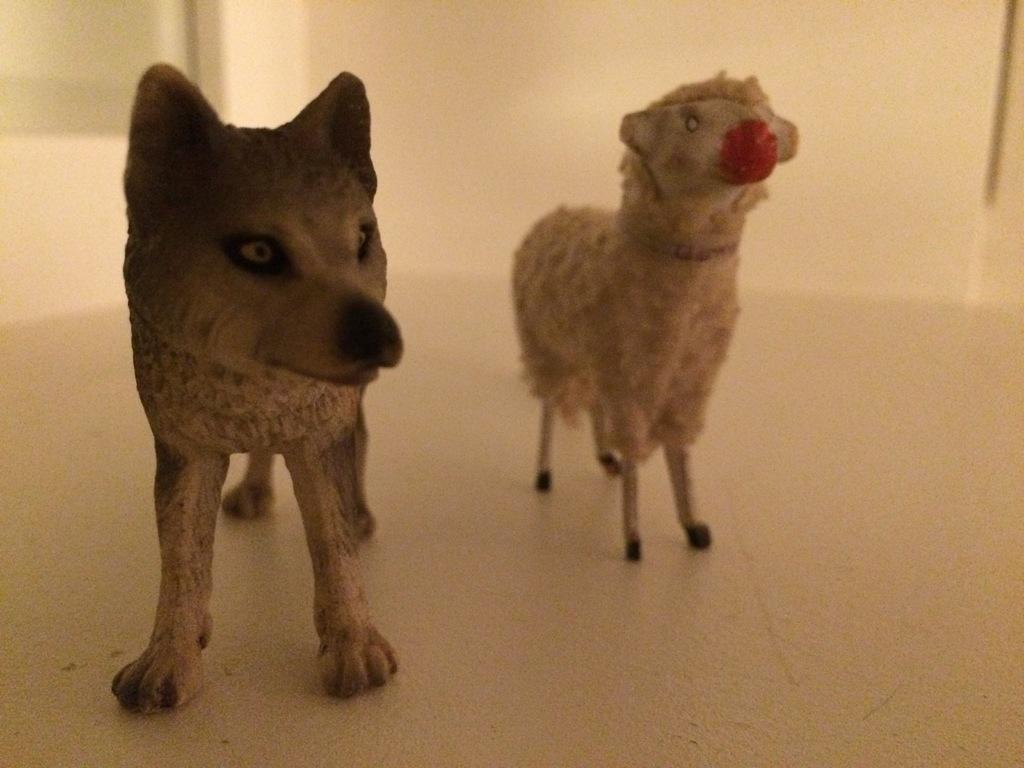What type of objects are present on the floor in the image? There are two animal dolls on the floor in the image. Can you describe the position of the animal dolls in the image? The animal dolls are placed on the floor. What type of produce can be seen in the image? There is no produce present in the image; it features two animal dolls placed on the floor. 